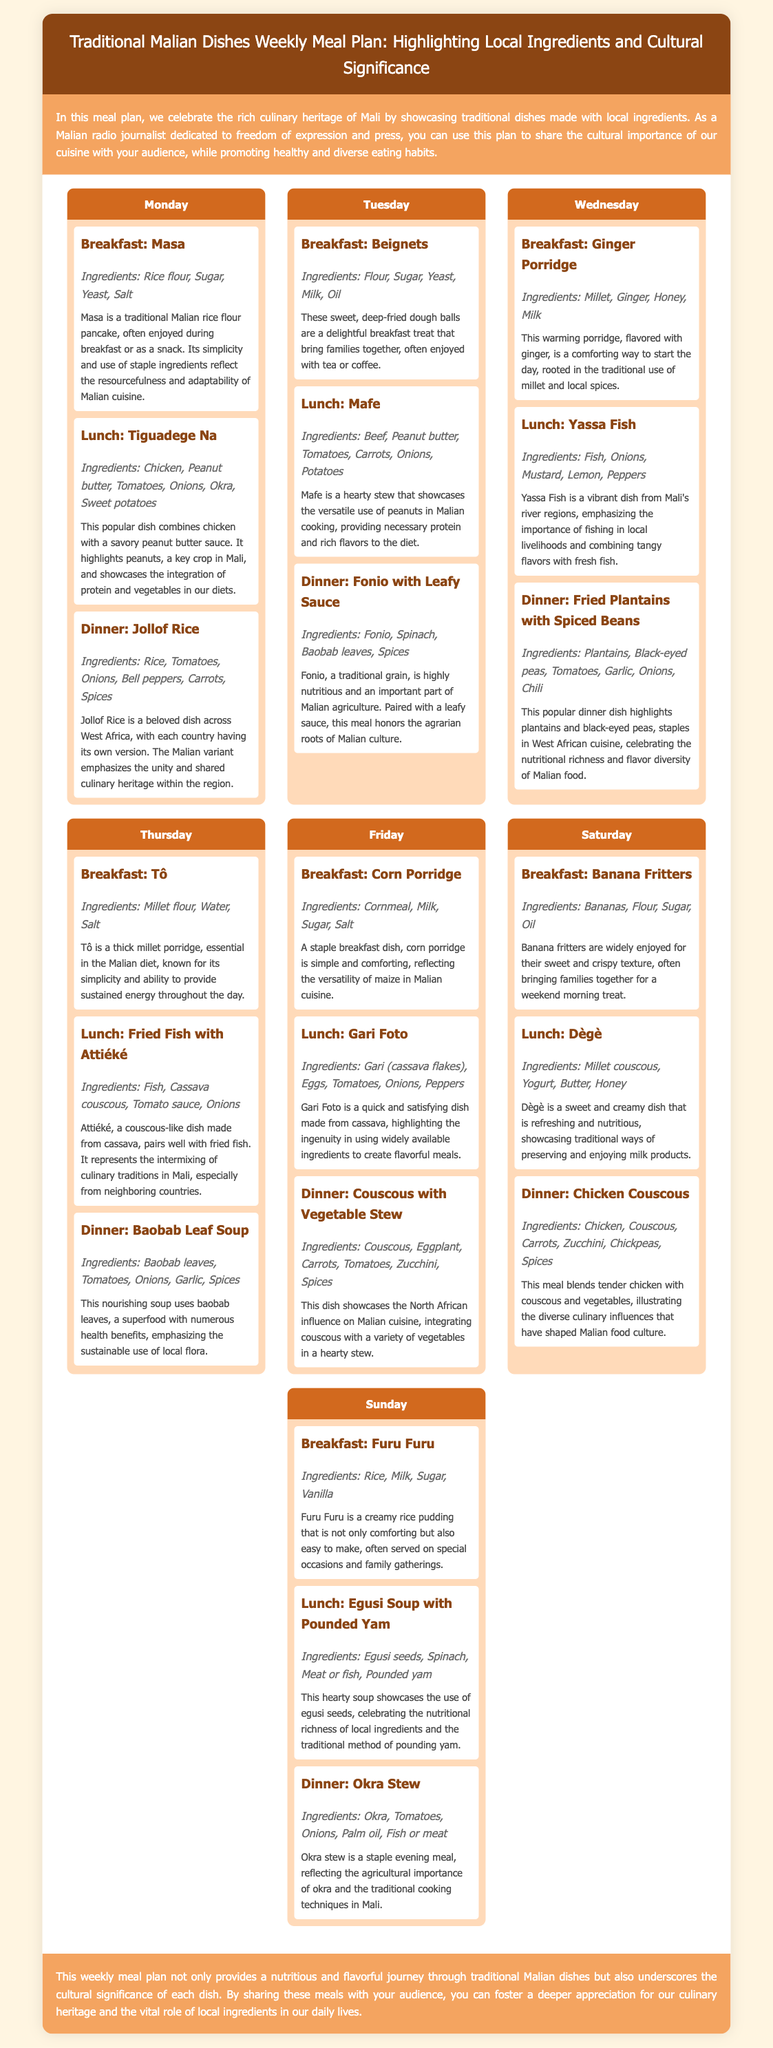What is the title of the document? The title of the document is found in the header section, which outlines the main theme of the content.
Answer: Traditional Malian Dishes Weekly Meal Plan: Highlighting Local Ingredients and Cultural Significance What dish is served for breakfast on Monday? The breakfast options are detailed for each day, including the specific dish served on Monday.
Answer: Masa What are the main ingredients of Tiguadege Na? Tiguadege Na is listed with its respective ingredients to provide insights into its preparation.
Answer: Chicken, Peanut butter, Tomatoes, Onions, Okra, Sweet potatoes Which dish reflects the unity of West African culinary heritage? The cultural significance section explains the regional importance and connections of certain dishes.
Answer: Jollof Rice How many meals are suggested for each day? The document's structure provides three meals for each day of the week.
Answer: 3 What is a cultural significance of Fonio with Leafy Sauce? The cultural significance section describes the traditional importance of specific meals, including Fonio with Leafy Sauce.
Answer: Honors the agrarian roots of Malian culture What is the primary ingredient in Baobab Leaf Soup? The ingredients for Baobab Leaf Soup are provided to highlight its main component.
Answer: Baobab leaves Which dish is associated with the use of egusi seeds? The cultural significance section helps identify dishes linked to specific local ingredients.
Answer: Egusi Soup with Pounded Yam What is the recommended meal for dinner on Saturday? The document lists the dinner options, allowing for identification of the meal for Saturday.
Answer: Chicken Couscous 